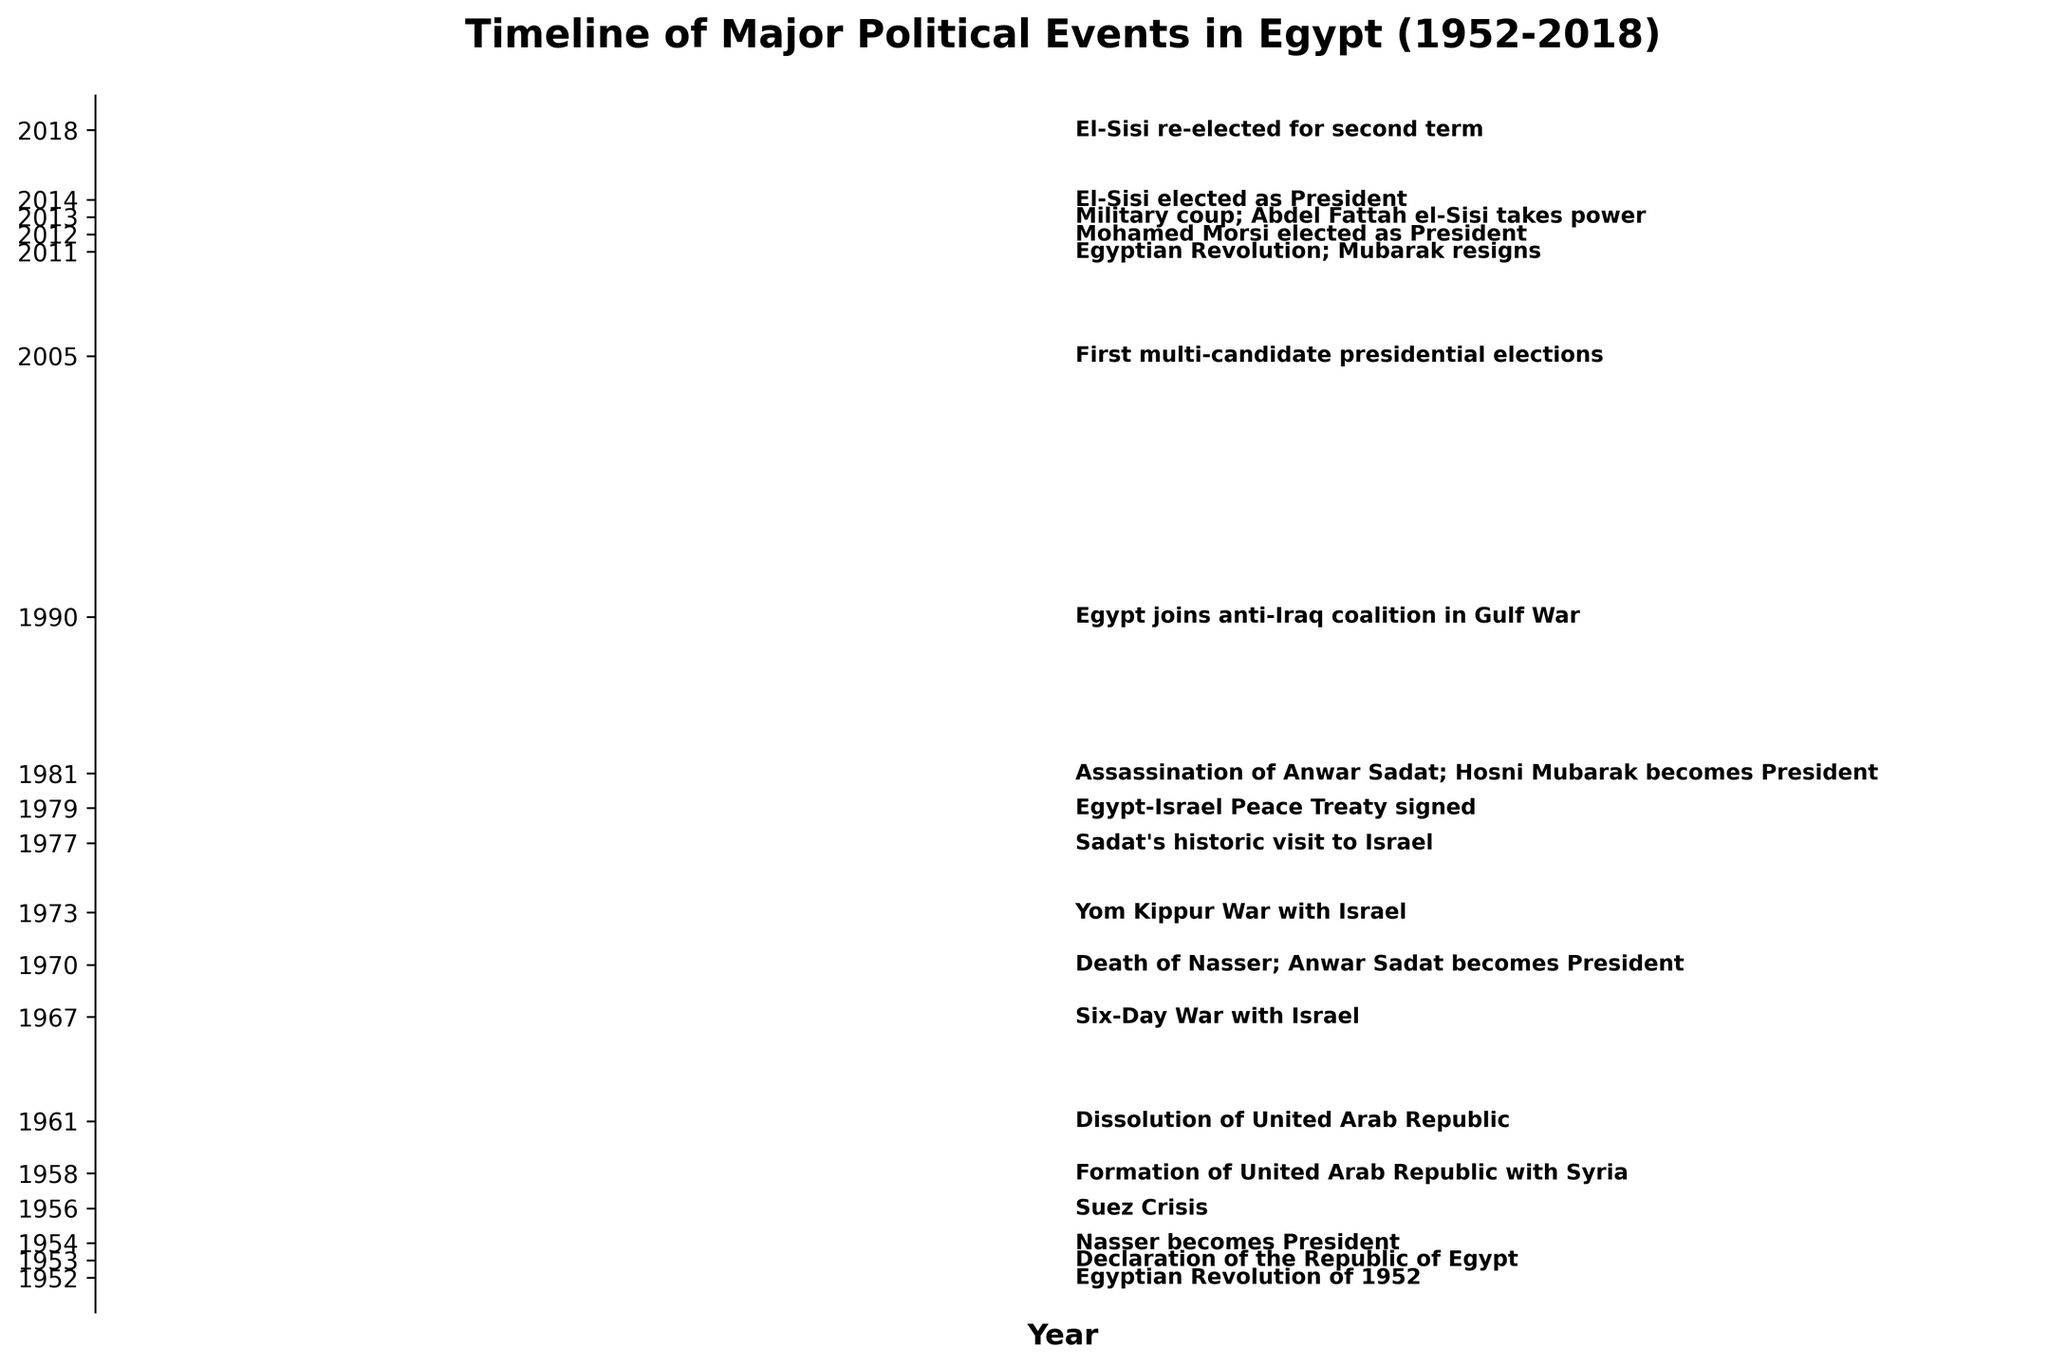what's the title of the figure? The title is usually placed at the top of the plot. In this case, it states "Timeline of Major Political Events in Egypt (1952-2018)"
Answer: Timeline of Major Political Events in Egypt (1952-2018) Which event marked the beginning of the timeline? The first event listed at the bottom of the timeline corresponds to the year 1952, indicating the "Egyptian Revolution of 1952."
Answer: Egyptian Revolution of 1952 How many Presidents are mentioned in the events? Scanning through the events, we find references to several Presidents: Nasser (1954), Sadat (1970), Mubarak (1981), Morsi (2012), and El-Sisi (2013, 2014, and 2018). Counting them totals to 5 presidents.
Answer: 5 What is the shortest interval between two consecutive events? Looking at the dates, the shortest interval is between "Morsi elected as President" in 2012 and "Military coup; Abdel Fattah el-Sisi takes power" in 2013, which is 1 year.
Answer: 1 year How many years passed between the Suez Crisis and the signing of the Egypt-Israel Peace Treaty? The Suez Crisis occurred in 1956, and the Egypt-Israel Peace Treaty was signed in 1979. Calculating the difference, 1979 - 1956 = 23 years.
Answer: 23 years Which event directly follows the Yom Kippur War with Israel? The Yom Kippur War took place in 1973. The next event listed in 1977 is "Sadat's historic visit to Israel."
Answer: Sadat's historic visit to Israel How many events are depicted in the plot? Each tick on the vertical axis represents an event; counting them gives 18 events from 1952 to 2018.
Answer: 18 events Which event occurred in 2011? The year 2011 on the timeline points to the "Egyptian Revolution; Mubarak resigns."
Answer: Egyptian Revolution; Mubarak resigns How many events took place during Nasser's presidency? Nasser's presidency began in 1954 until his death in 1970. Events during this period include the Suez Crisis (1956), Formation of the United Arab Republic with Syria (1958), and its dissolution (1961), and the Six-Day War with Israel (1967). This totals 4 events.
Answer: 4 events Between which years did the United Arab Republic exist? The Formation of the United Arab Republic with Syria is marked in 1958, and its dissolution is marked in 1961, meaning the union lasted from 1958 to 1961.
Answer: 1958 to 1961 